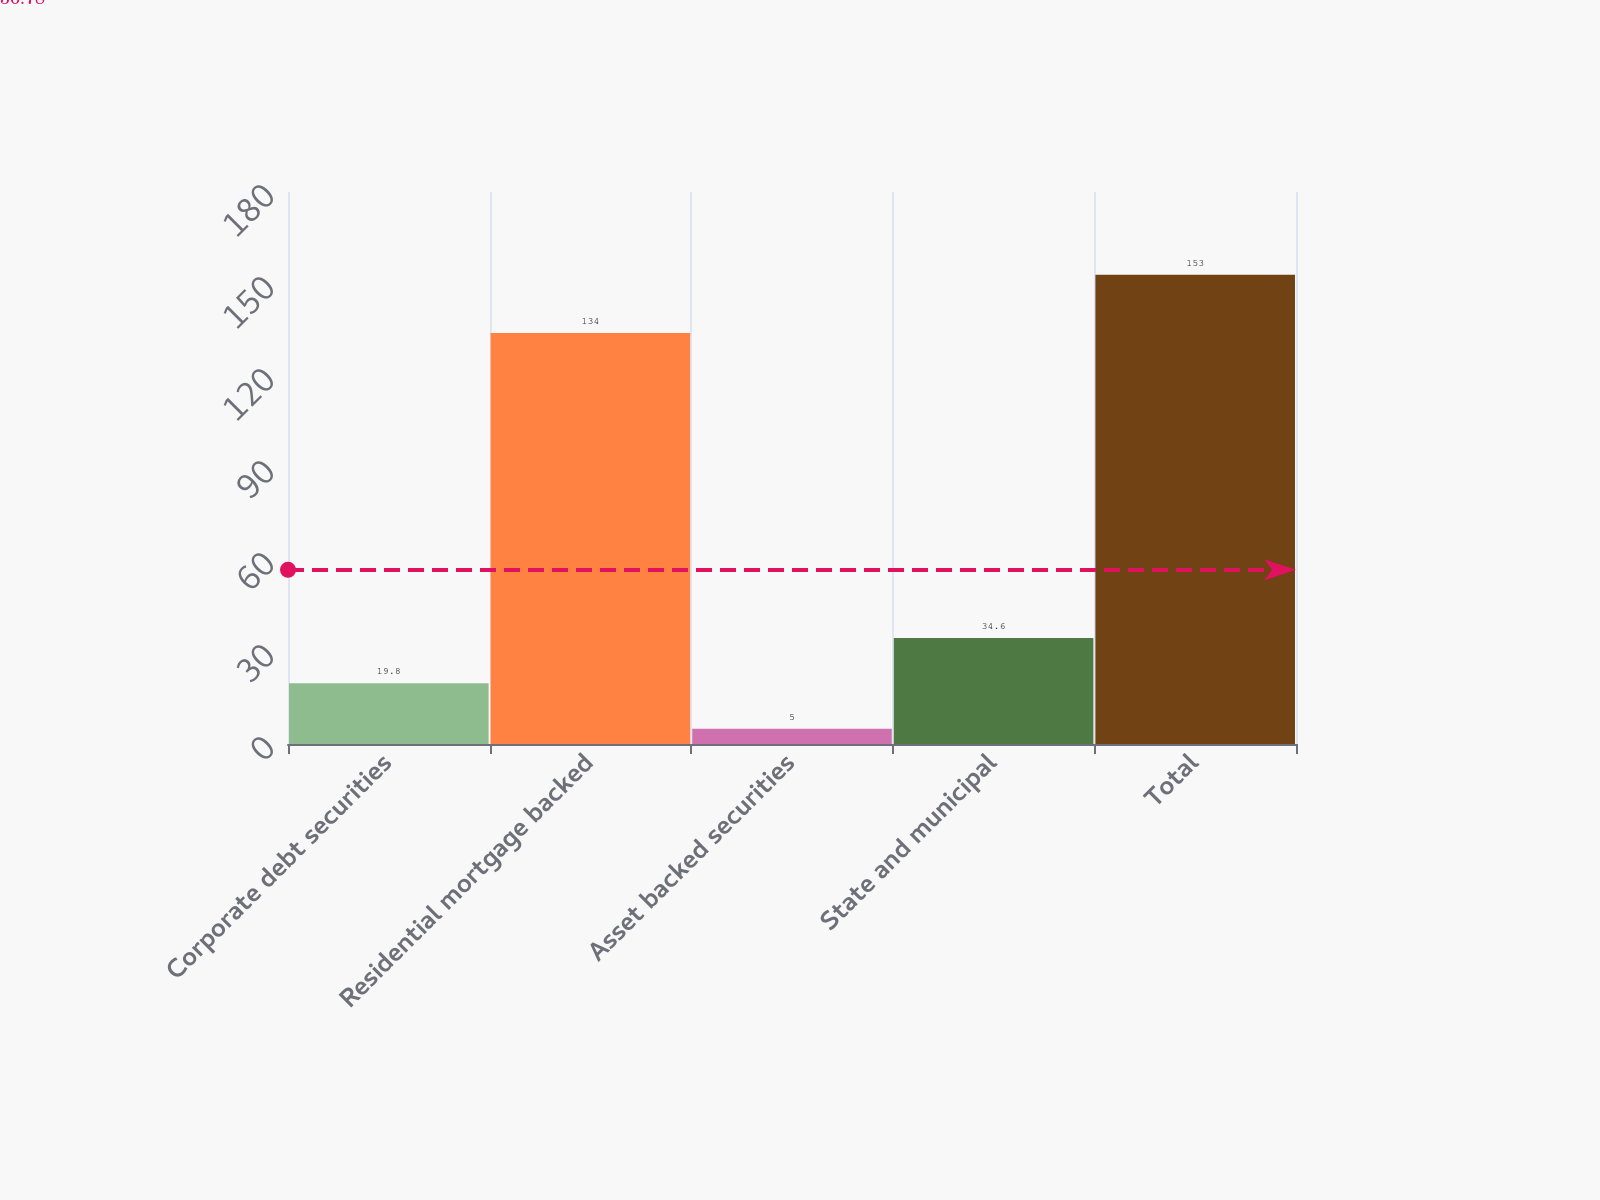Convert chart to OTSL. <chart><loc_0><loc_0><loc_500><loc_500><bar_chart><fcel>Corporate debt securities<fcel>Residential mortgage backed<fcel>Asset backed securities<fcel>State and municipal<fcel>Total<nl><fcel>19.8<fcel>134<fcel>5<fcel>34.6<fcel>153<nl></chart> 